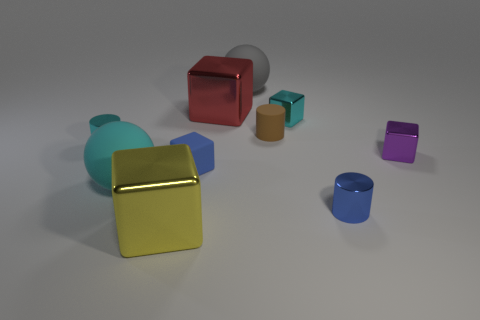Subtract all green cubes. Subtract all cyan balls. How many cubes are left? 5 Subtract all spheres. How many objects are left? 8 Add 3 large gray rubber balls. How many large gray rubber balls are left? 4 Add 3 big balls. How many big balls exist? 5 Subtract 0 green blocks. How many objects are left? 10 Subtract all blue objects. Subtract all rubber cylinders. How many objects are left? 7 